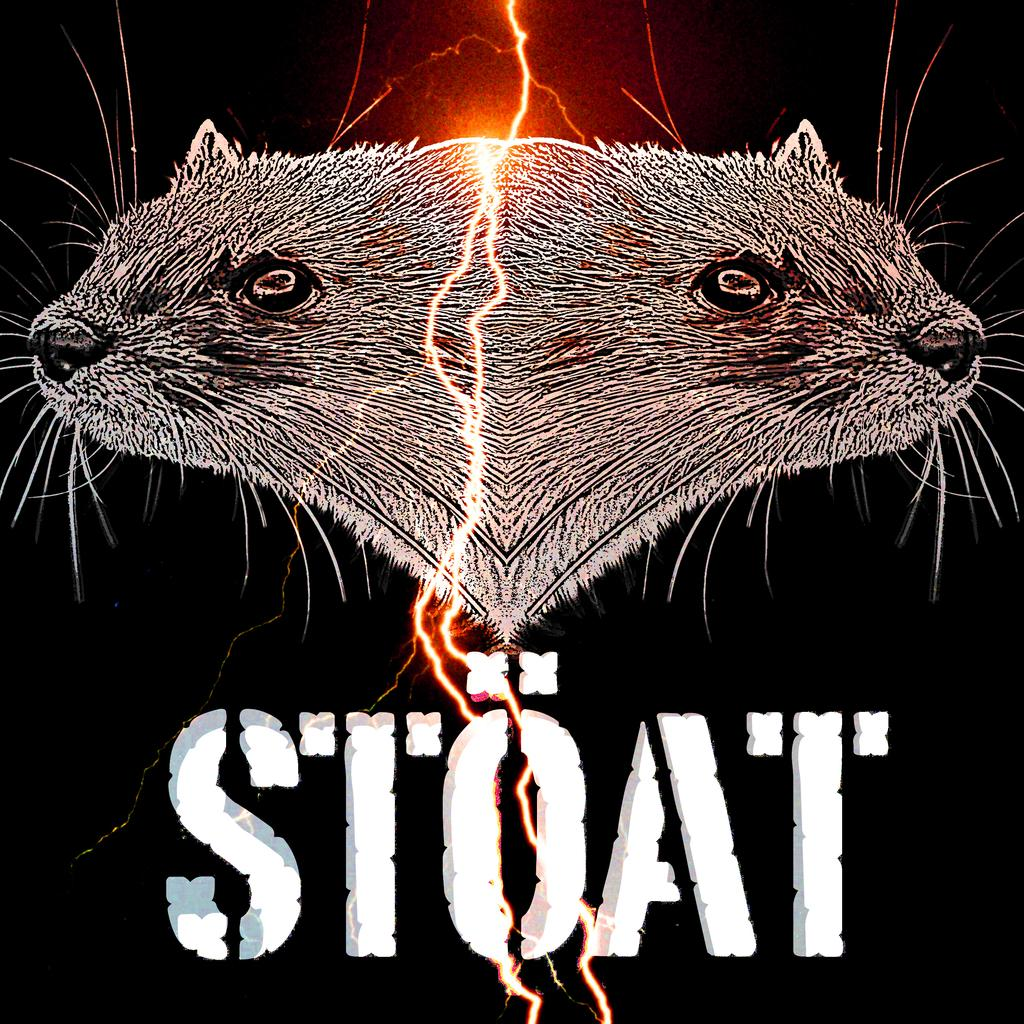What type of objects are depicted in the image? There are two animal heads in the image. Is there any other element between the animal heads? Yes, there is a light between the animal heads. What word is written below the image? The word "stoat" is written below the image. What type of flame can be seen coming from the father's hand in the image? There is no father or flame present in the image; it only features two animal heads and a light. 